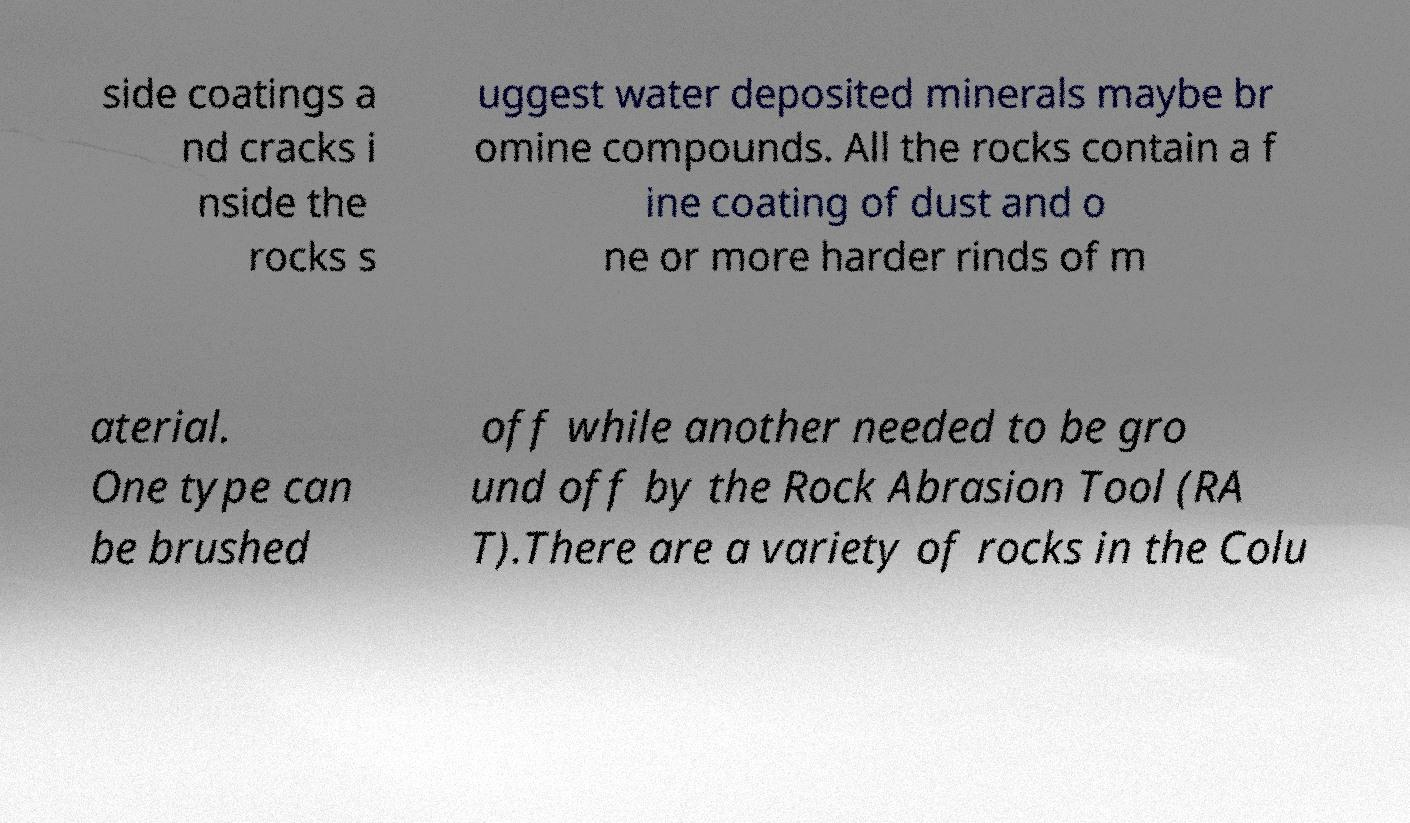Please identify and transcribe the text found in this image. side coatings a nd cracks i nside the rocks s uggest water deposited minerals maybe br omine compounds. All the rocks contain a f ine coating of dust and o ne or more harder rinds of m aterial. One type can be brushed off while another needed to be gro und off by the Rock Abrasion Tool (RA T).There are a variety of rocks in the Colu 